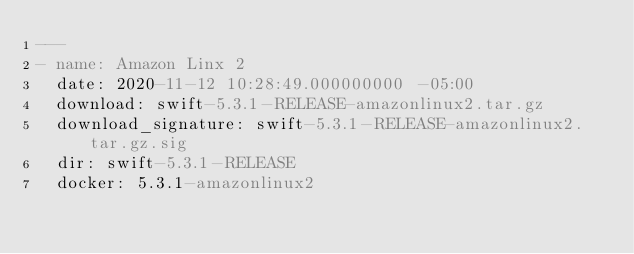Convert code to text. <code><loc_0><loc_0><loc_500><loc_500><_YAML_>---
- name: Amazon Linx 2
  date: 2020-11-12 10:28:49.000000000 -05:00
  download: swift-5.3.1-RELEASE-amazonlinux2.tar.gz
  download_signature: swift-5.3.1-RELEASE-amazonlinux2.tar.gz.sig
  dir: swift-5.3.1-RELEASE
  docker: 5.3.1-amazonlinux2
</code> 